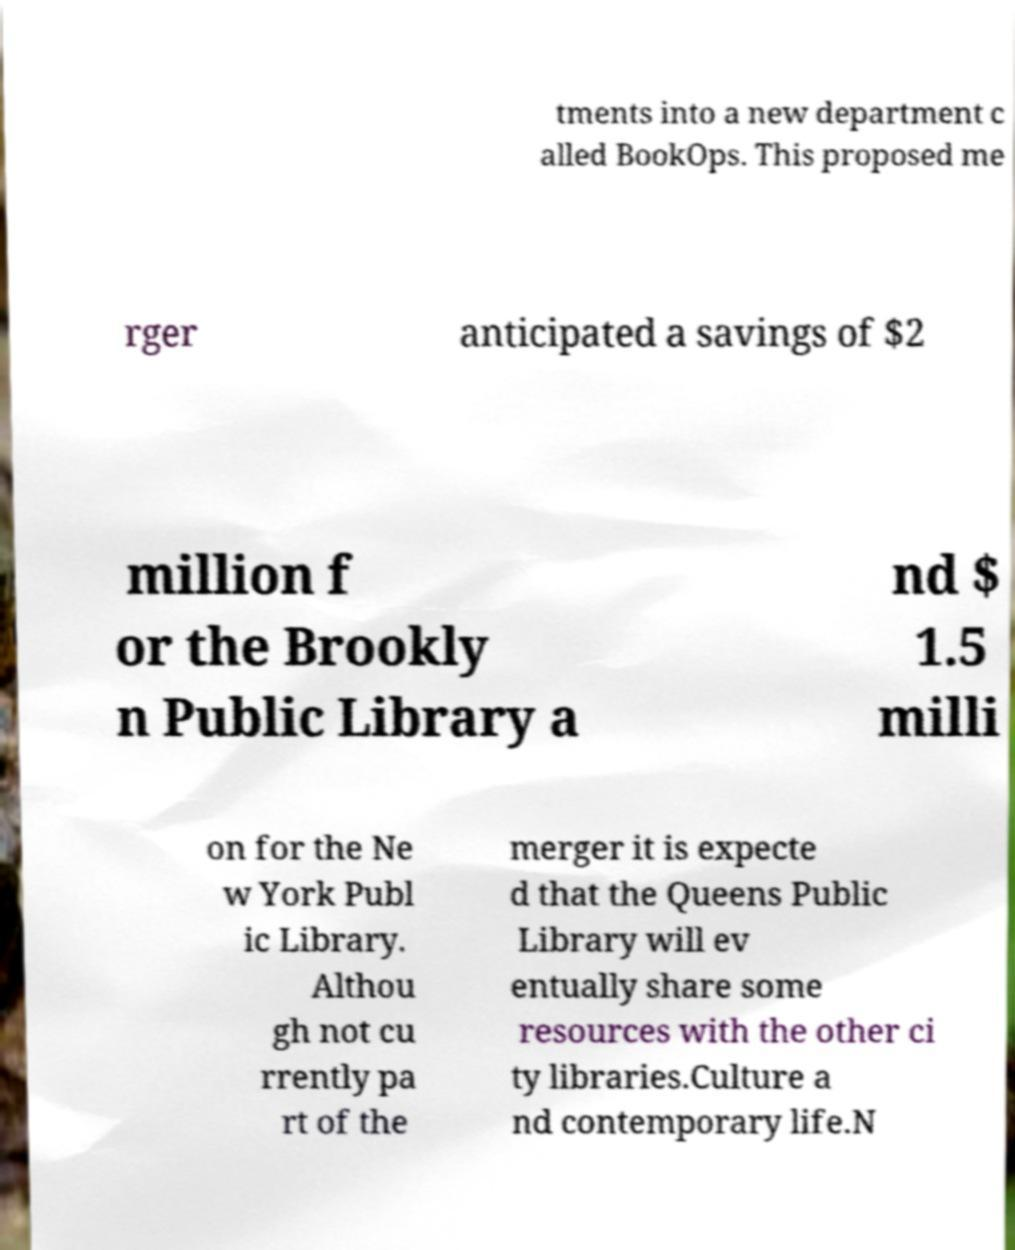Please read and relay the text visible in this image. What does it say? tments into a new department c alled BookOps. This proposed me rger anticipated a savings of $2 million f or the Brookly n Public Library a nd $ 1.5 milli on for the Ne w York Publ ic Library. Althou gh not cu rrently pa rt of the merger it is expecte d that the Queens Public Library will ev entually share some resources with the other ci ty libraries.Culture a nd contemporary life.N 